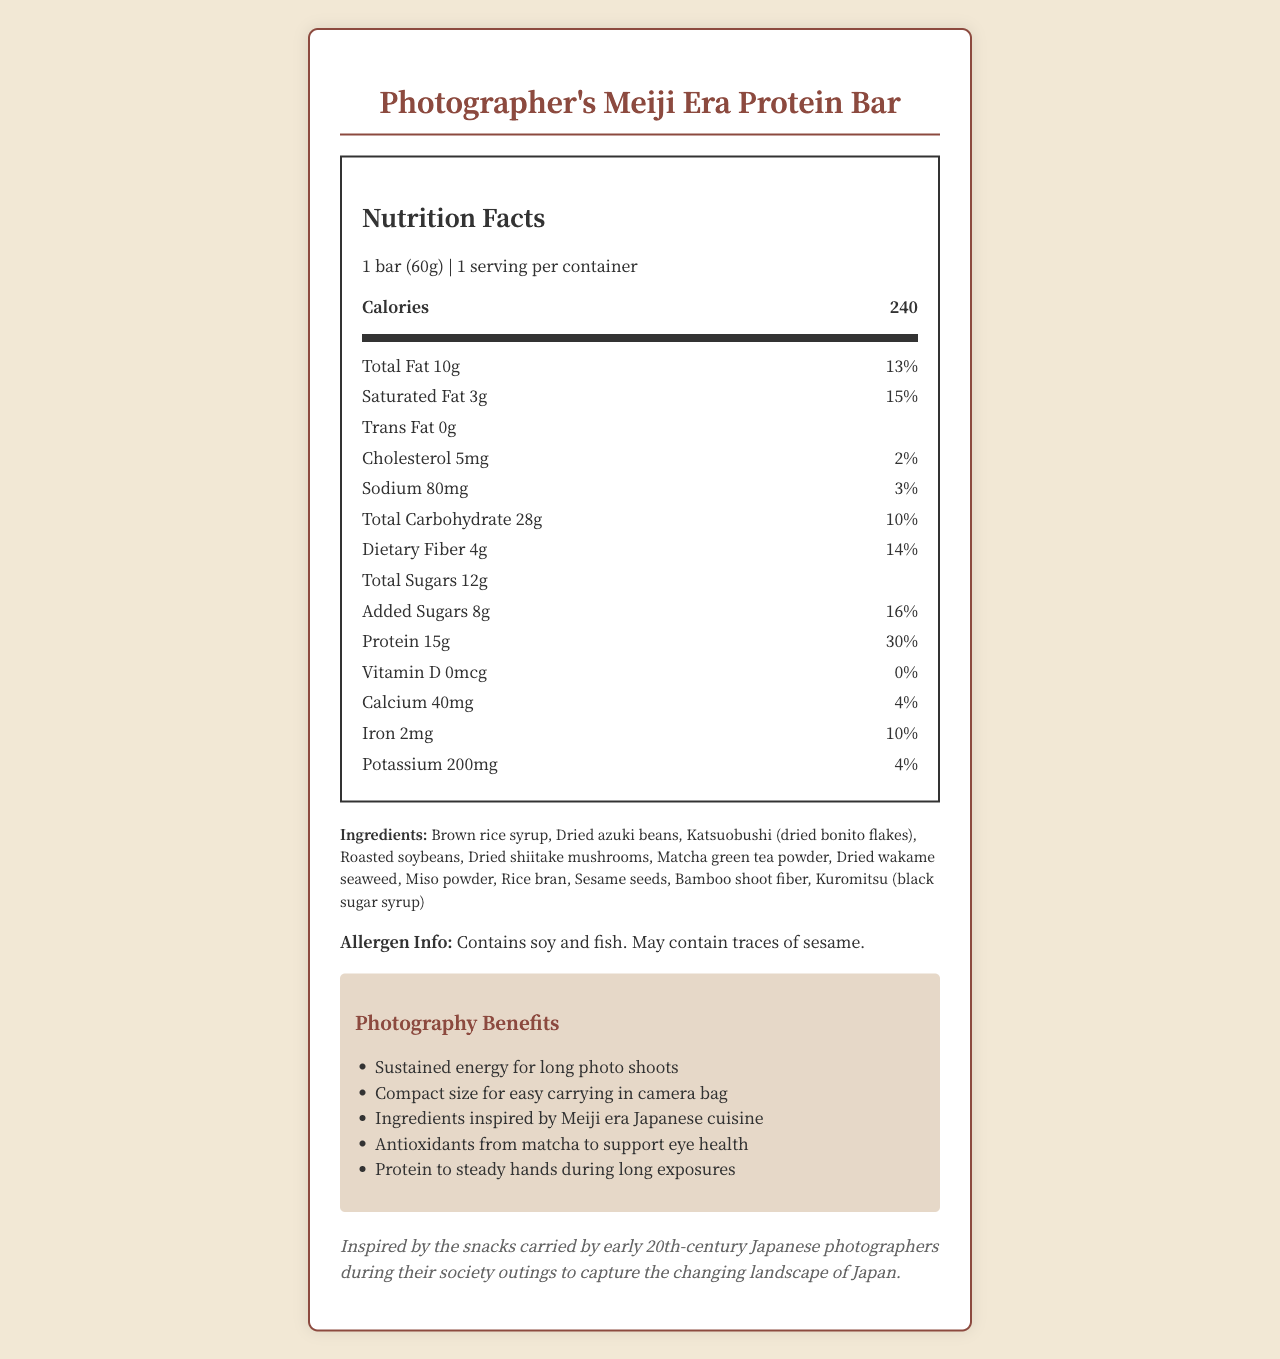How many calories are in one serving of the Photographer's Meiji Era Protein Bar? The label specifies that there are 240 calories in one serving of the protein bar.
Answer: 240 How much protein does the Photographer's Meiji Era Protein Bar provide per serving? The label indicates that the bar provides 15 grams of protein per serving, which contributes to 30% of the daily value.
Answer: 15g What percentage of the daily value for iron does one bar provide? The nutrition label states that the bar provides 2mg of iron which is 10% of the daily value.
Answer: 10% What are the ingredients of the Photographer's Meiji Era Protein Bar? The label lists all these ingredients under the ingredients section.
Answer: Brown rice syrup, Dried azuki beans, Katsuobushi (dried bonito flakes), Roasted soybeans, Dried shiitake mushrooms, Matcha green tea powder, Dried wakame seaweed, Miso powder, Rice bran, Sesame seeds, Bamboo shoot fiber, Kuromitsu (black sugar syrup) Is there any vitamin D in the Photographer's Meiji Era Protein Bar? The label specifies that there is 0mcg of vitamin D, contributing 0% of the daily value.
Answer: No How many grams of dietary fiber are in one serving of the protein bar? A. 2g B. 4g C. 5g D. 6g The label indicates that each bar contains 4 grams of dietary fiber, which is 14% of the daily value.
Answer: B. 4g Which of the following ingredients is NOT listed in the protein bar? A. Brown rice syrup B. Miso powder C. Green beans D. Matcha green tea powder Green beans are not listed among the ingredients of the protein bar.
Answer: C. Green beans Does the protein bar contain any added sugars? The label specifies that the bar contains 8g of added sugars, which is 16% of the daily value.
Answer: Yes Summarize the main purpose of the Photographer's Meiji Era Protein Bar. The nutrition facts indicate various amounts of nutrients, while the ingredients list highlights traditional Japanese items. The additional benefits underline its value for photography.
Answer: The Photographer's Meiji Era Protein Bar is designed to provide sustained energy with high protein content and ingredients inspired by early 20th-century Japanese cuisine, tailored for photographers' needs during long photo shoots. What is the main source of fiber in the protein bar? The document lists multiple sources that could contribute to the dietary fiber, such as dried wakame seaweed, dried shiitake mushrooms, and bamboo shoot fiber, but does not specify which one is the main source.
Answer: Cannot be determined 